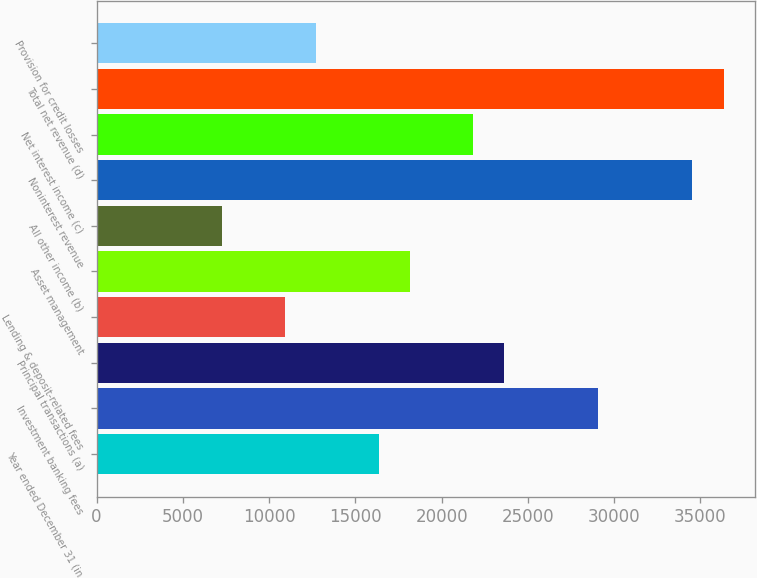Convert chart to OTSL. <chart><loc_0><loc_0><loc_500><loc_500><bar_chart><fcel>Year ended December 31 (in<fcel>Investment banking fees<fcel>Principal transactions (a)<fcel>Lending & deposit-related fees<fcel>Asset management<fcel>All other income (b)<fcel>Noninterest revenue<fcel>Net interest income (c)<fcel>Total net revenue (d)<fcel>Provision for credit losses<nl><fcel>16353<fcel>29071.8<fcel>23620.9<fcel>10902.2<fcel>18170<fcel>7268.27<fcel>34522.6<fcel>21803.9<fcel>36339.6<fcel>12719.1<nl></chart> 